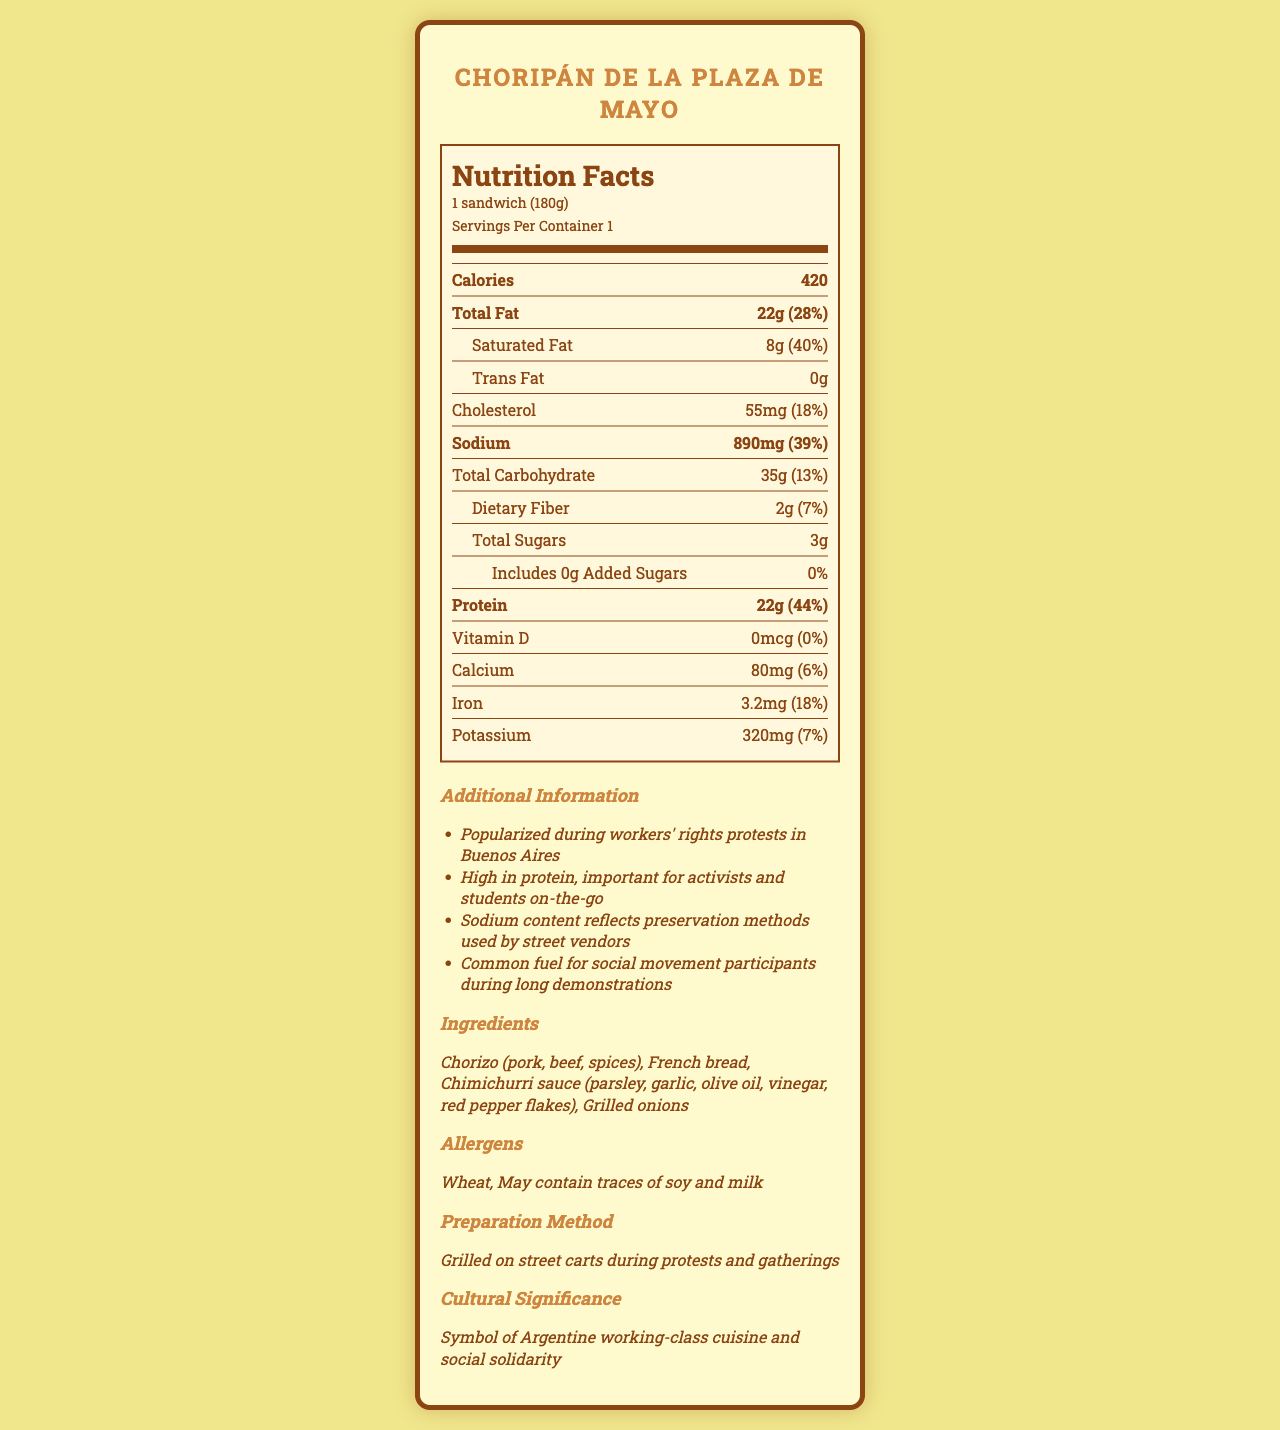what is the serving size of Choripán de la Plaza de Mayo? The serving size is listed at the top of the Nutrition Facts label under the product name.
Answer: 1 sandwich (180g) what is the sodium content in one serving of Choripán de la Plaza de Mayo? The sodium content is listed under the "Sodium" section in the Nutrition Facts label.
Answer: 890 mg how much protein does one serving of Choripán de la Plaza de Mayo contain? The protein content is listed under the "Protein" section in the Nutrition Facts label.
Answer: 22 g what percentage of the daily value for sodium is provided by one serving of Choripán de la Plaza de Mayo? The daily value percentage for sodium is listed next to the sodium content.
Answer: 39% how many total calories are in one serving of Choripán de la Plaza de Mayo? The total calorie content is listed at the top of the Nutrition Facts label under the header.
Answer: 420 which ingredient is not part of the Choripán de la Plaza de Mayo? A. Chorizo B. French bread C. Lettuce D. Chimichurri sauce The list of ingredients includes Chorizo, French bread, and Chimichurri sauce but does not mention lettuce.
Answer: C what are the allergens present in the Choripán de la Plaza de Mayo? A. Wheat B. Soy C. Milk D. All of the above The allergens section mentions wheat and may contain traces of soy and milk.
Answer: D does the Choripán de la Plaza de Mayo contain any added sugars? The label lists 0g of added sugars in the Nutrition Facts.
Answer: No is Choripán de la Plaza de Mayo high in protein? With 22g of protein (44% daily value), the Choripán is high in protein.
Answer: Yes summarize the main idea of the document. The Nutrition Facts label is detailed, showing the nutritional content of Choripán de la Plaza de Mayo with a focus on sodium and protein levels. The additional information provides cultural context and preparation details of the food.
Answer: The document provides the Nutrition Facts for Choripán de la Plaza de Mayo, a popular street food in Argentina. It includes details on serving size, calorie content, and nutrient breakdown, highlighting significant amounts of sodium and protein. Additionally, it mentions cultural significance, ingredients, allergens, and preparation methods. why is the sodium content in Choripán de la Plaza de Mayo high? The label mentions the sodium content but does not provide a specific reason for its high level.
Answer: Not enough information how does Choripán de la Plaza de Mayo support social movement participants during demonstrations? The additional information section states that it is high in protein, which is beneficial for activists and students during long demonstrations.
Answer: High in protein, important for activists and students on-the-go what is the cultural significance of Choripán de la Plaza de Mayo? The document mentions that Choripán de la Plaza de Mayo is a symbol of Argentine working-class cuisine and social solidarity.
Answer: Symbol of Argentine working-class cuisine and social solidarity 